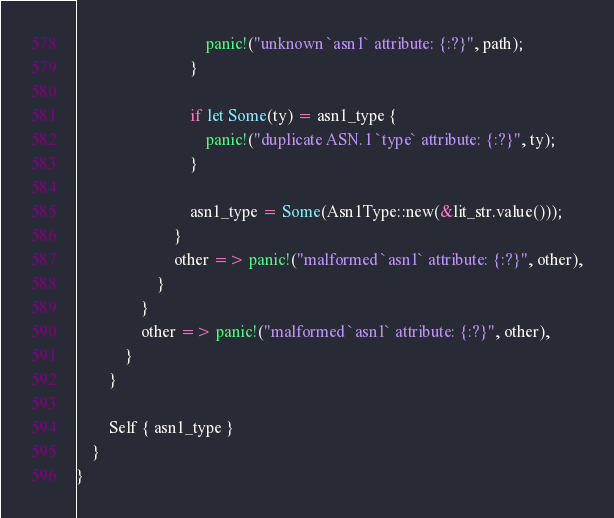<code> <loc_0><loc_0><loc_500><loc_500><_Rust_>                                panic!("unknown `asn1` attribute: {:?}", path);
                            }

                            if let Some(ty) = asn1_type {
                                panic!("duplicate ASN.1 `type` attribute: {:?}", ty);
                            }

                            asn1_type = Some(Asn1Type::new(&lit_str.value()));
                        }
                        other => panic!("malformed `asn1` attribute: {:?}", other),
                    }
                }
                other => panic!("malformed `asn1` attribute: {:?}", other),
            }
        }

        Self { asn1_type }
    }
}
</code> 